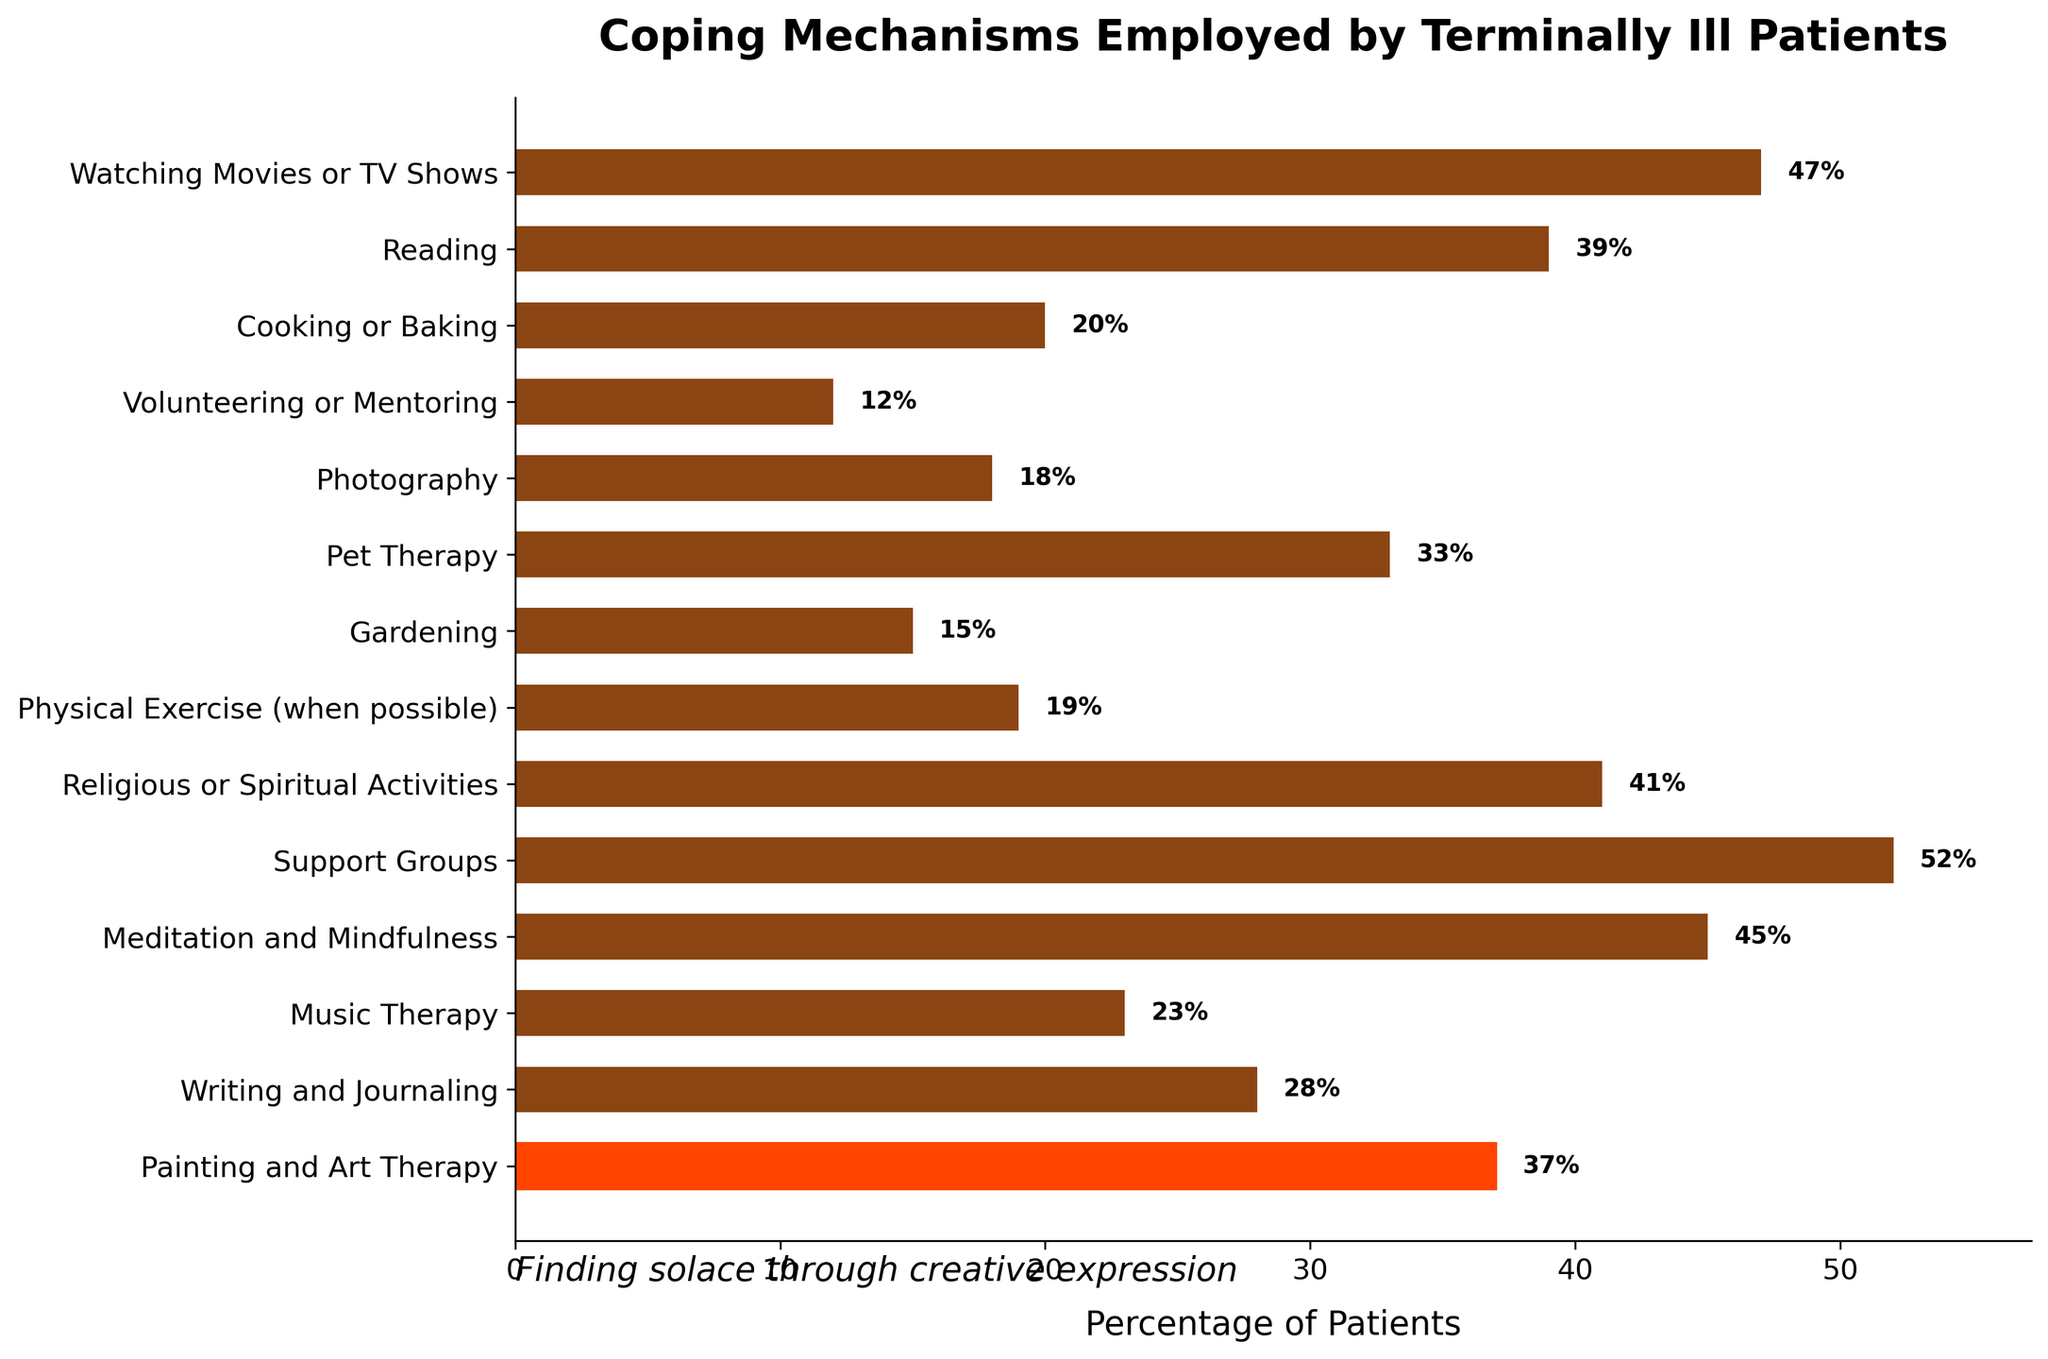What's the percentage of patients using Meditation and Mindfulness as a coping mechanism? To find the percentage for Meditation and Mindfulness, look at the corresponding bar. The label on the bar is "Meditation and Mindfulness", and the value at the end of the bar shows 45%.
Answer: 45% Which coping mechanism is employed by the highest percentage of patients? Compare the lengths of the bars or the percentages shown at the end of each bar. The longest bar corresponds to Support Groups, which also has the highest percentage value of 52%.
Answer: Support Groups How many coping mechanisms have a percentage greater than 30%? Identify all the bars that extend beyond the 30% mark. The coping mechanisms with percentages greater than 30% are Painting and Art Therapy (37%), Meditation and Mindfulness (45%), Support Groups (52%), Religious or Spiritual Activities (41%), Pet Therapy (33%), and Reading (39%). Counting these, there are 6 coping mechanisms.
Answer: 6 Is Painting and Art Therapy more popular than Writing and Journaling among the patients? Compare the lengths and percentage values of the bars for Painting and Art Therapy (37%) and Writing and Journaling (28%). Since 37% is greater than 28%, Painting and Art Therapy is more popular.
Answer: Yes What is the combined percentage of patients who use Cooking or Baking and Gardening as coping mechanisms? Add the percentages for Cooking or Baking (20%) and Gardening (15%). The combined percentage is 20% + 15% = 35%.
Answer: 35% Which coping mechanism is highlighted in a different color in the chart? Examine the visual attributes of the bars. The bar for Painting and Art Therapy is highlighted in a distinct color (orange) compared to the other bars.
Answer: Painting and Art Therapy What is the difference in percentage between patients using Watching Movies or TV Shows and those using Writing and Journaling? Subtract the percentage of Writing and Journaling (28%) from the percentage of Watching Movies or TV Shows (47%). The difference is 47% - 28% = 19%.
Answer: 19% Are more patients employing Religious or Spiritual Activities or Physical Exercise as coping mechanisms? Compare the percentage values for Religious or Spiritual Activities (41%) and Physical Exercise (19%). Since 41% is greater than 19%, more patients are employing Religious or Spiritual Activities.
Answer: Religious or Spiritual Activities Which coping mechanism has the lowest percentage of patients? Find the shortest bar or the smallest percentage value. Volunteering or Mentoring has the lowest percentage with 12%.
Answer: Volunteering or Mentoring 